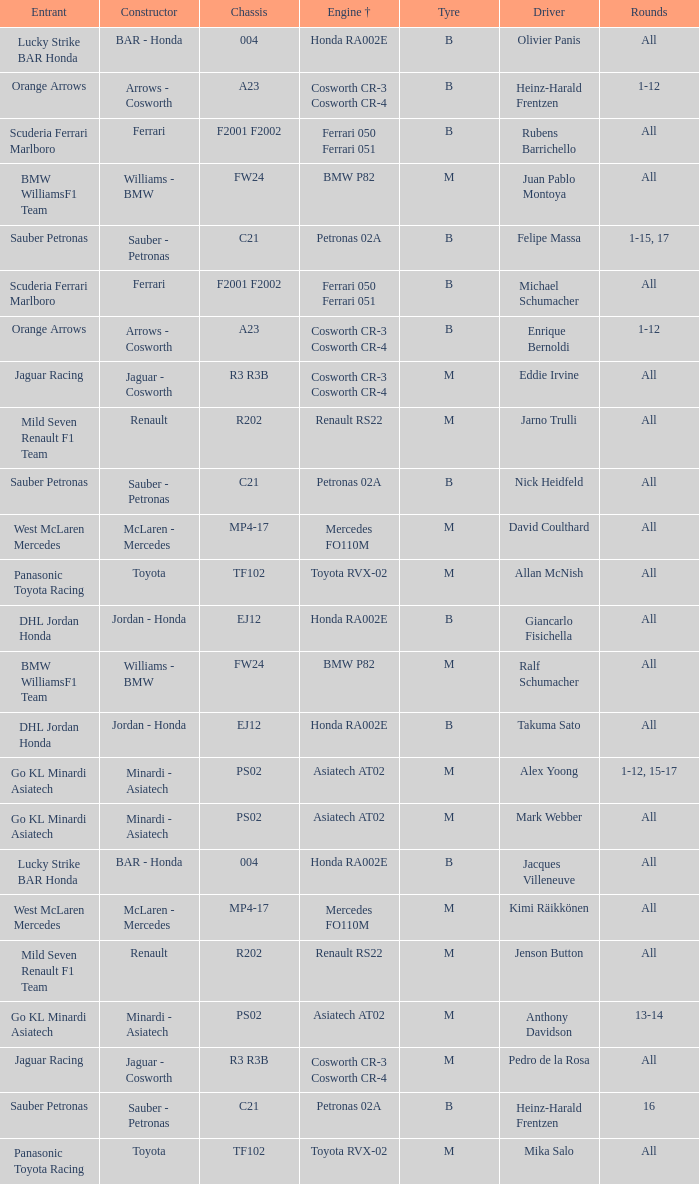What is the engine when the rounds ar all, the tyre is m and the driver is david coulthard? Mercedes FO110M. 